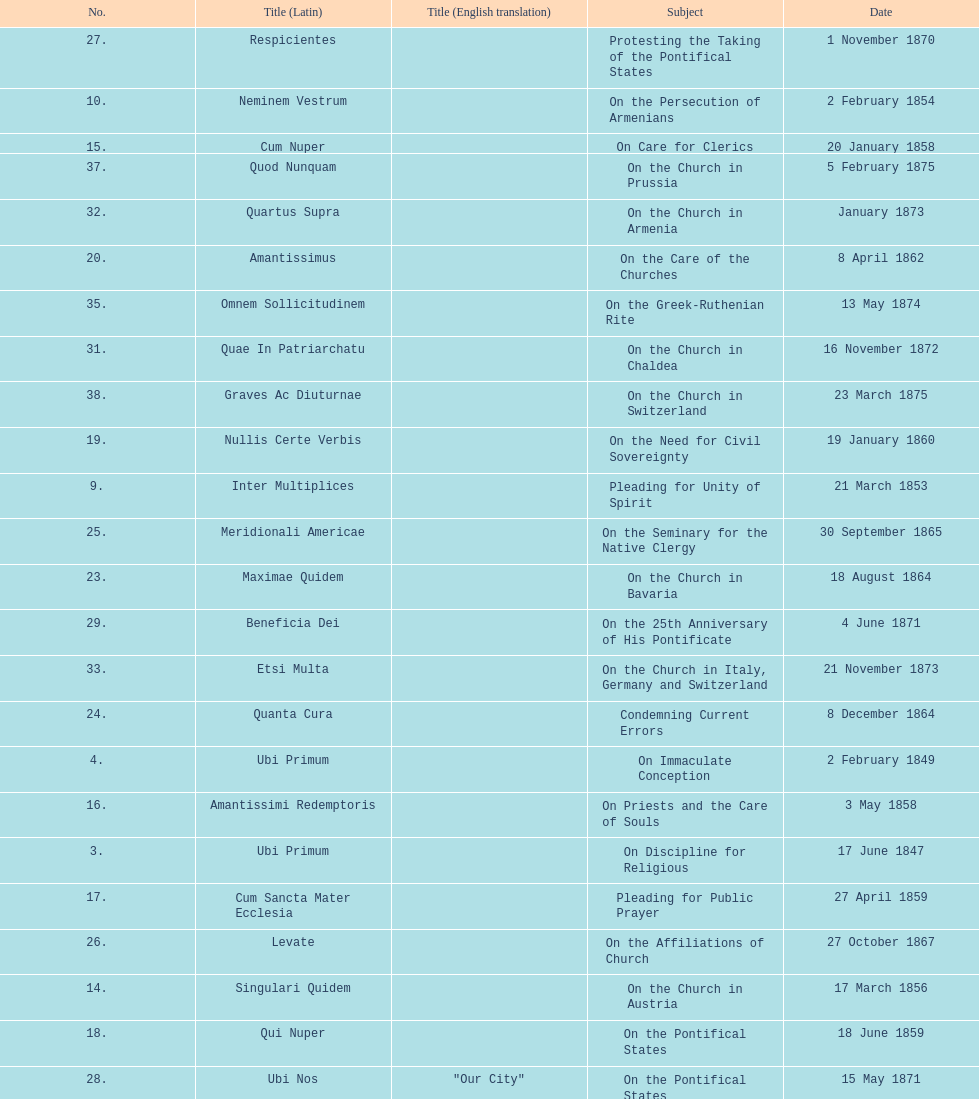Total number of encyclicals on churches . 11. 